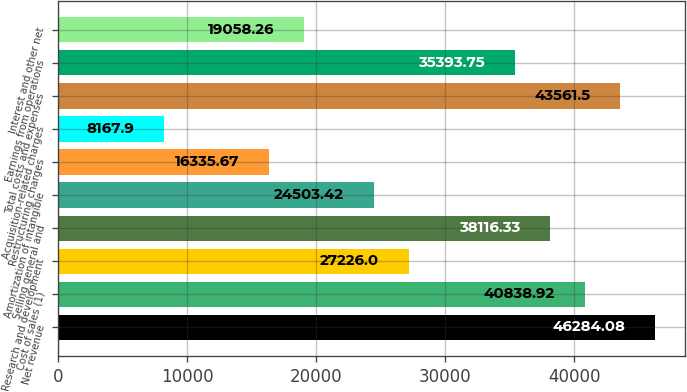Convert chart. <chart><loc_0><loc_0><loc_500><loc_500><bar_chart><fcel>Net revenue<fcel>Cost of sales (1)<fcel>Research and development<fcel>Selling general and<fcel>Amortization of intangible<fcel>Restructuring charges<fcel>Acquisition-related charges<fcel>Total costs and expenses<fcel>Earnings from operations<fcel>Interest and other net<nl><fcel>46284.1<fcel>40838.9<fcel>27226<fcel>38116.3<fcel>24503.4<fcel>16335.7<fcel>8167.9<fcel>43561.5<fcel>35393.8<fcel>19058.3<nl></chart> 